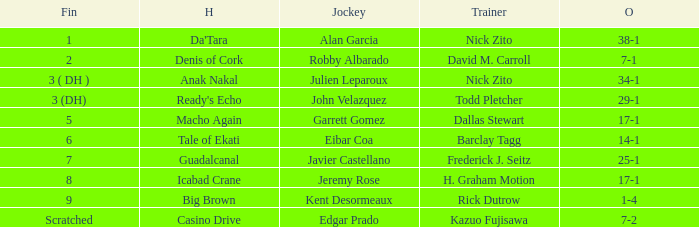What are the Odds for the Horse called Ready's Echo? 29-1. 